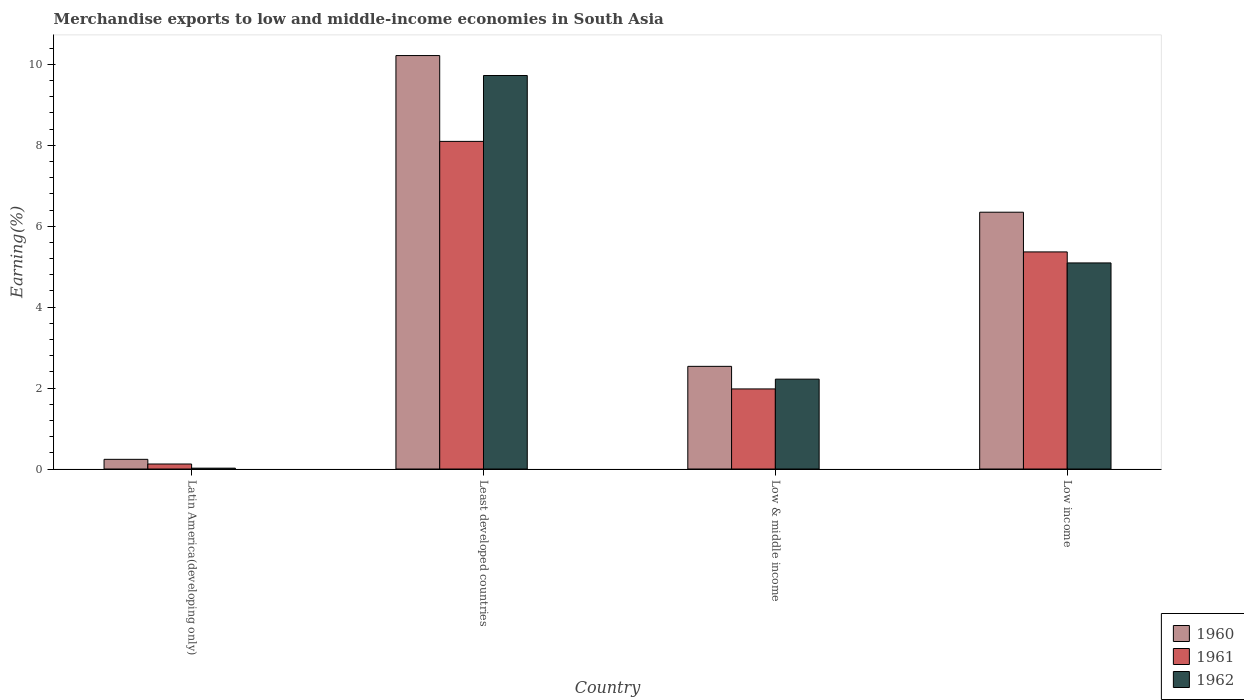What is the label of the 1st group of bars from the left?
Make the answer very short. Latin America(developing only). What is the percentage of amount earned from merchandise exports in 1962 in Low income?
Provide a short and direct response. 5.09. Across all countries, what is the maximum percentage of amount earned from merchandise exports in 1960?
Your answer should be compact. 10.22. Across all countries, what is the minimum percentage of amount earned from merchandise exports in 1962?
Keep it short and to the point. 0.02. In which country was the percentage of amount earned from merchandise exports in 1962 maximum?
Your answer should be compact. Least developed countries. In which country was the percentage of amount earned from merchandise exports in 1961 minimum?
Offer a terse response. Latin America(developing only). What is the total percentage of amount earned from merchandise exports in 1961 in the graph?
Keep it short and to the point. 15.57. What is the difference between the percentage of amount earned from merchandise exports in 1961 in Low & middle income and that in Low income?
Offer a very short reply. -3.39. What is the difference between the percentage of amount earned from merchandise exports in 1960 in Low income and the percentage of amount earned from merchandise exports in 1962 in Latin America(developing only)?
Keep it short and to the point. 6.33. What is the average percentage of amount earned from merchandise exports in 1960 per country?
Keep it short and to the point. 4.84. What is the difference between the percentage of amount earned from merchandise exports of/in 1961 and percentage of amount earned from merchandise exports of/in 1962 in Least developed countries?
Make the answer very short. -1.63. In how many countries, is the percentage of amount earned from merchandise exports in 1960 greater than 8.4 %?
Ensure brevity in your answer.  1. What is the ratio of the percentage of amount earned from merchandise exports in 1960 in Latin America(developing only) to that in Low income?
Give a very brief answer. 0.04. Is the difference between the percentage of amount earned from merchandise exports in 1961 in Latin America(developing only) and Low income greater than the difference between the percentage of amount earned from merchandise exports in 1962 in Latin America(developing only) and Low income?
Your answer should be compact. No. What is the difference between the highest and the second highest percentage of amount earned from merchandise exports in 1961?
Offer a terse response. 6.12. What is the difference between the highest and the lowest percentage of amount earned from merchandise exports in 1962?
Offer a terse response. 9.7. What does the 3rd bar from the right in Low & middle income represents?
Make the answer very short. 1960. Are all the bars in the graph horizontal?
Make the answer very short. No. Are the values on the major ticks of Y-axis written in scientific E-notation?
Provide a short and direct response. No. Where does the legend appear in the graph?
Give a very brief answer. Bottom right. What is the title of the graph?
Keep it short and to the point. Merchandise exports to low and middle-income economies in South Asia. What is the label or title of the X-axis?
Make the answer very short. Country. What is the label or title of the Y-axis?
Provide a short and direct response. Earning(%). What is the Earning(%) of 1960 in Latin America(developing only)?
Make the answer very short. 0.24. What is the Earning(%) of 1961 in Latin America(developing only)?
Provide a short and direct response. 0.12. What is the Earning(%) of 1962 in Latin America(developing only)?
Provide a succinct answer. 0.02. What is the Earning(%) of 1960 in Least developed countries?
Offer a very short reply. 10.22. What is the Earning(%) in 1961 in Least developed countries?
Ensure brevity in your answer.  8.1. What is the Earning(%) of 1962 in Least developed countries?
Offer a terse response. 9.73. What is the Earning(%) of 1960 in Low & middle income?
Keep it short and to the point. 2.54. What is the Earning(%) in 1961 in Low & middle income?
Provide a succinct answer. 1.98. What is the Earning(%) of 1962 in Low & middle income?
Your response must be concise. 2.22. What is the Earning(%) of 1960 in Low income?
Provide a short and direct response. 6.35. What is the Earning(%) in 1961 in Low income?
Your answer should be compact. 5.37. What is the Earning(%) of 1962 in Low income?
Provide a succinct answer. 5.09. Across all countries, what is the maximum Earning(%) of 1960?
Provide a short and direct response. 10.22. Across all countries, what is the maximum Earning(%) of 1961?
Keep it short and to the point. 8.1. Across all countries, what is the maximum Earning(%) in 1962?
Your response must be concise. 9.73. Across all countries, what is the minimum Earning(%) of 1960?
Your answer should be very brief. 0.24. Across all countries, what is the minimum Earning(%) in 1961?
Offer a very short reply. 0.12. Across all countries, what is the minimum Earning(%) of 1962?
Ensure brevity in your answer.  0.02. What is the total Earning(%) of 1960 in the graph?
Your response must be concise. 19.34. What is the total Earning(%) in 1961 in the graph?
Your answer should be compact. 15.57. What is the total Earning(%) in 1962 in the graph?
Your answer should be very brief. 17.06. What is the difference between the Earning(%) of 1960 in Latin America(developing only) and that in Least developed countries?
Offer a very short reply. -9.98. What is the difference between the Earning(%) of 1961 in Latin America(developing only) and that in Least developed countries?
Keep it short and to the point. -7.97. What is the difference between the Earning(%) of 1962 in Latin America(developing only) and that in Least developed countries?
Offer a very short reply. -9.7. What is the difference between the Earning(%) of 1960 in Latin America(developing only) and that in Low & middle income?
Offer a very short reply. -2.3. What is the difference between the Earning(%) in 1961 in Latin America(developing only) and that in Low & middle income?
Keep it short and to the point. -1.86. What is the difference between the Earning(%) in 1962 in Latin America(developing only) and that in Low & middle income?
Ensure brevity in your answer.  -2.2. What is the difference between the Earning(%) in 1960 in Latin America(developing only) and that in Low income?
Your answer should be compact. -6.11. What is the difference between the Earning(%) in 1961 in Latin America(developing only) and that in Low income?
Keep it short and to the point. -5.24. What is the difference between the Earning(%) of 1962 in Latin America(developing only) and that in Low income?
Your answer should be very brief. -5.07. What is the difference between the Earning(%) of 1960 in Least developed countries and that in Low & middle income?
Keep it short and to the point. 7.68. What is the difference between the Earning(%) in 1961 in Least developed countries and that in Low & middle income?
Give a very brief answer. 6.12. What is the difference between the Earning(%) in 1962 in Least developed countries and that in Low & middle income?
Provide a succinct answer. 7.5. What is the difference between the Earning(%) of 1960 in Least developed countries and that in Low income?
Your response must be concise. 3.87. What is the difference between the Earning(%) in 1961 in Least developed countries and that in Low income?
Ensure brevity in your answer.  2.73. What is the difference between the Earning(%) of 1962 in Least developed countries and that in Low income?
Your answer should be very brief. 4.63. What is the difference between the Earning(%) of 1960 in Low & middle income and that in Low income?
Give a very brief answer. -3.81. What is the difference between the Earning(%) in 1961 in Low & middle income and that in Low income?
Offer a very short reply. -3.39. What is the difference between the Earning(%) in 1962 in Low & middle income and that in Low income?
Offer a very short reply. -2.87. What is the difference between the Earning(%) in 1960 in Latin America(developing only) and the Earning(%) in 1961 in Least developed countries?
Your answer should be compact. -7.86. What is the difference between the Earning(%) in 1960 in Latin America(developing only) and the Earning(%) in 1962 in Least developed countries?
Your answer should be very brief. -9.49. What is the difference between the Earning(%) in 1961 in Latin America(developing only) and the Earning(%) in 1962 in Least developed countries?
Give a very brief answer. -9.6. What is the difference between the Earning(%) of 1960 in Latin America(developing only) and the Earning(%) of 1961 in Low & middle income?
Make the answer very short. -1.74. What is the difference between the Earning(%) of 1960 in Latin America(developing only) and the Earning(%) of 1962 in Low & middle income?
Your answer should be compact. -1.98. What is the difference between the Earning(%) in 1961 in Latin America(developing only) and the Earning(%) in 1962 in Low & middle income?
Give a very brief answer. -2.1. What is the difference between the Earning(%) in 1960 in Latin America(developing only) and the Earning(%) in 1961 in Low income?
Give a very brief answer. -5.13. What is the difference between the Earning(%) of 1960 in Latin America(developing only) and the Earning(%) of 1962 in Low income?
Your response must be concise. -4.85. What is the difference between the Earning(%) of 1961 in Latin America(developing only) and the Earning(%) of 1962 in Low income?
Offer a terse response. -4.97. What is the difference between the Earning(%) of 1960 in Least developed countries and the Earning(%) of 1961 in Low & middle income?
Offer a terse response. 8.24. What is the difference between the Earning(%) in 1960 in Least developed countries and the Earning(%) in 1962 in Low & middle income?
Provide a succinct answer. 8. What is the difference between the Earning(%) in 1961 in Least developed countries and the Earning(%) in 1962 in Low & middle income?
Your response must be concise. 5.88. What is the difference between the Earning(%) in 1960 in Least developed countries and the Earning(%) in 1961 in Low income?
Your answer should be very brief. 4.85. What is the difference between the Earning(%) in 1960 in Least developed countries and the Earning(%) in 1962 in Low income?
Keep it short and to the point. 5.13. What is the difference between the Earning(%) in 1961 in Least developed countries and the Earning(%) in 1962 in Low income?
Your answer should be very brief. 3. What is the difference between the Earning(%) in 1960 in Low & middle income and the Earning(%) in 1961 in Low income?
Provide a succinct answer. -2.83. What is the difference between the Earning(%) in 1960 in Low & middle income and the Earning(%) in 1962 in Low income?
Offer a very short reply. -2.56. What is the difference between the Earning(%) of 1961 in Low & middle income and the Earning(%) of 1962 in Low income?
Keep it short and to the point. -3.11. What is the average Earning(%) of 1960 per country?
Your answer should be compact. 4.84. What is the average Earning(%) in 1961 per country?
Offer a very short reply. 3.89. What is the average Earning(%) of 1962 per country?
Keep it short and to the point. 4.27. What is the difference between the Earning(%) in 1960 and Earning(%) in 1961 in Latin America(developing only)?
Give a very brief answer. 0.12. What is the difference between the Earning(%) of 1960 and Earning(%) of 1962 in Latin America(developing only)?
Offer a very short reply. 0.22. What is the difference between the Earning(%) of 1961 and Earning(%) of 1962 in Latin America(developing only)?
Make the answer very short. 0.1. What is the difference between the Earning(%) of 1960 and Earning(%) of 1961 in Least developed countries?
Your answer should be compact. 2.12. What is the difference between the Earning(%) in 1960 and Earning(%) in 1962 in Least developed countries?
Make the answer very short. 0.49. What is the difference between the Earning(%) of 1961 and Earning(%) of 1962 in Least developed countries?
Provide a succinct answer. -1.63. What is the difference between the Earning(%) in 1960 and Earning(%) in 1961 in Low & middle income?
Provide a short and direct response. 0.56. What is the difference between the Earning(%) in 1960 and Earning(%) in 1962 in Low & middle income?
Offer a terse response. 0.32. What is the difference between the Earning(%) of 1961 and Earning(%) of 1962 in Low & middle income?
Make the answer very short. -0.24. What is the difference between the Earning(%) in 1960 and Earning(%) in 1961 in Low income?
Give a very brief answer. 0.98. What is the difference between the Earning(%) in 1960 and Earning(%) in 1962 in Low income?
Your answer should be very brief. 1.25. What is the difference between the Earning(%) in 1961 and Earning(%) in 1962 in Low income?
Offer a very short reply. 0.27. What is the ratio of the Earning(%) in 1960 in Latin America(developing only) to that in Least developed countries?
Your response must be concise. 0.02. What is the ratio of the Earning(%) in 1961 in Latin America(developing only) to that in Least developed countries?
Your response must be concise. 0.02. What is the ratio of the Earning(%) of 1962 in Latin America(developing only) to that in Least developed countries?
Your answer should be very brief. 0. What is the ratio of the Earning(%) of 1960 in Latin America(developing only) to that in Low & middle income?
Offer a terse response. 0.09. What is the ratio of the Earning(%) of 1961 in Latin America(developing only) to that in Low & middle income?
Make the answer very short. 0.06. What is the ratio of the Earning(%) in 1962 in Latin America(developing only) to that in Low & middle income?
Offer a very short reply. 0.01. What is the ratio of the Earning(%) in 1960 in Latin America(developing only) to that in Low income?
Keep it short and to the point. 0.04. What is the ratio of the Earning(%) of 1961 in Latin America(developing only) to that in Low income?
Your answer should be compact. 0.02. What is the ratio of the Earning(%) of 1962 in Latin America(developing only) to that in Low income?
Provide a succinct answer. 0. What is the ratio of the Earning(%) of 1960 in Least developed countries to that in Low & middle income?
Your answer should be compact. 4.03. What is the ratio of the Earning(%) of 1961 in Least developed countries to that in Low & middle income?
Provide a short and direct response. 4.09. What is the ratio of the Earning(%) of 1962 in Least developed countries to that in Low & middle income?
Offer a terse response. 4.38. What is the ratio of the Earning(%) of 1960 in Least developed countries to that in Low income?
Ensure brevity in your answer.  1.61. What is the ratio of the Earning(%) of 1961 in Least developed countries to that in Low income?
Make the answer very short. 1.51. What is the ratio of the Earning(%) of 1962 in Least developed countries to that in Low income?
Provide a succinct answer. 1.91. What is the ratio of the Earning(%) in 1960 in Low & middle income to that in Low income?
Your response must be concise. 0.4. What is the ratio of the Earning(%) of 1961 in Low & middle income to that in Low income?
Provide a short and direct response. 0.37. What is the ratio of the Earning(%) of 1962 in Low & middle income to that in Low income?
Offer a very short reply. 0.44. What is the difference between the highest and the second highest Earning(%) in 1960?
Offer a very short reply. 3.87. What is the difference between the highest and the second highest Earning(%) of 1961?
Provide a succinct answer. 2.73. What is the difference between the highest and the second highest Earning(%) in 1962?
Keep it short and to the point. 4.63. What is the difference between the highest and the lowest Earning(%) in 1960?
Your response must be concise. 9.98. What is the difference between the highest and the lowest Earning(%) of 1961?
Make the answer very short. 7.97. What is the difference between the highest and the lowest Earning(%) of 1962?
Give a very brief answer. 9.7. 